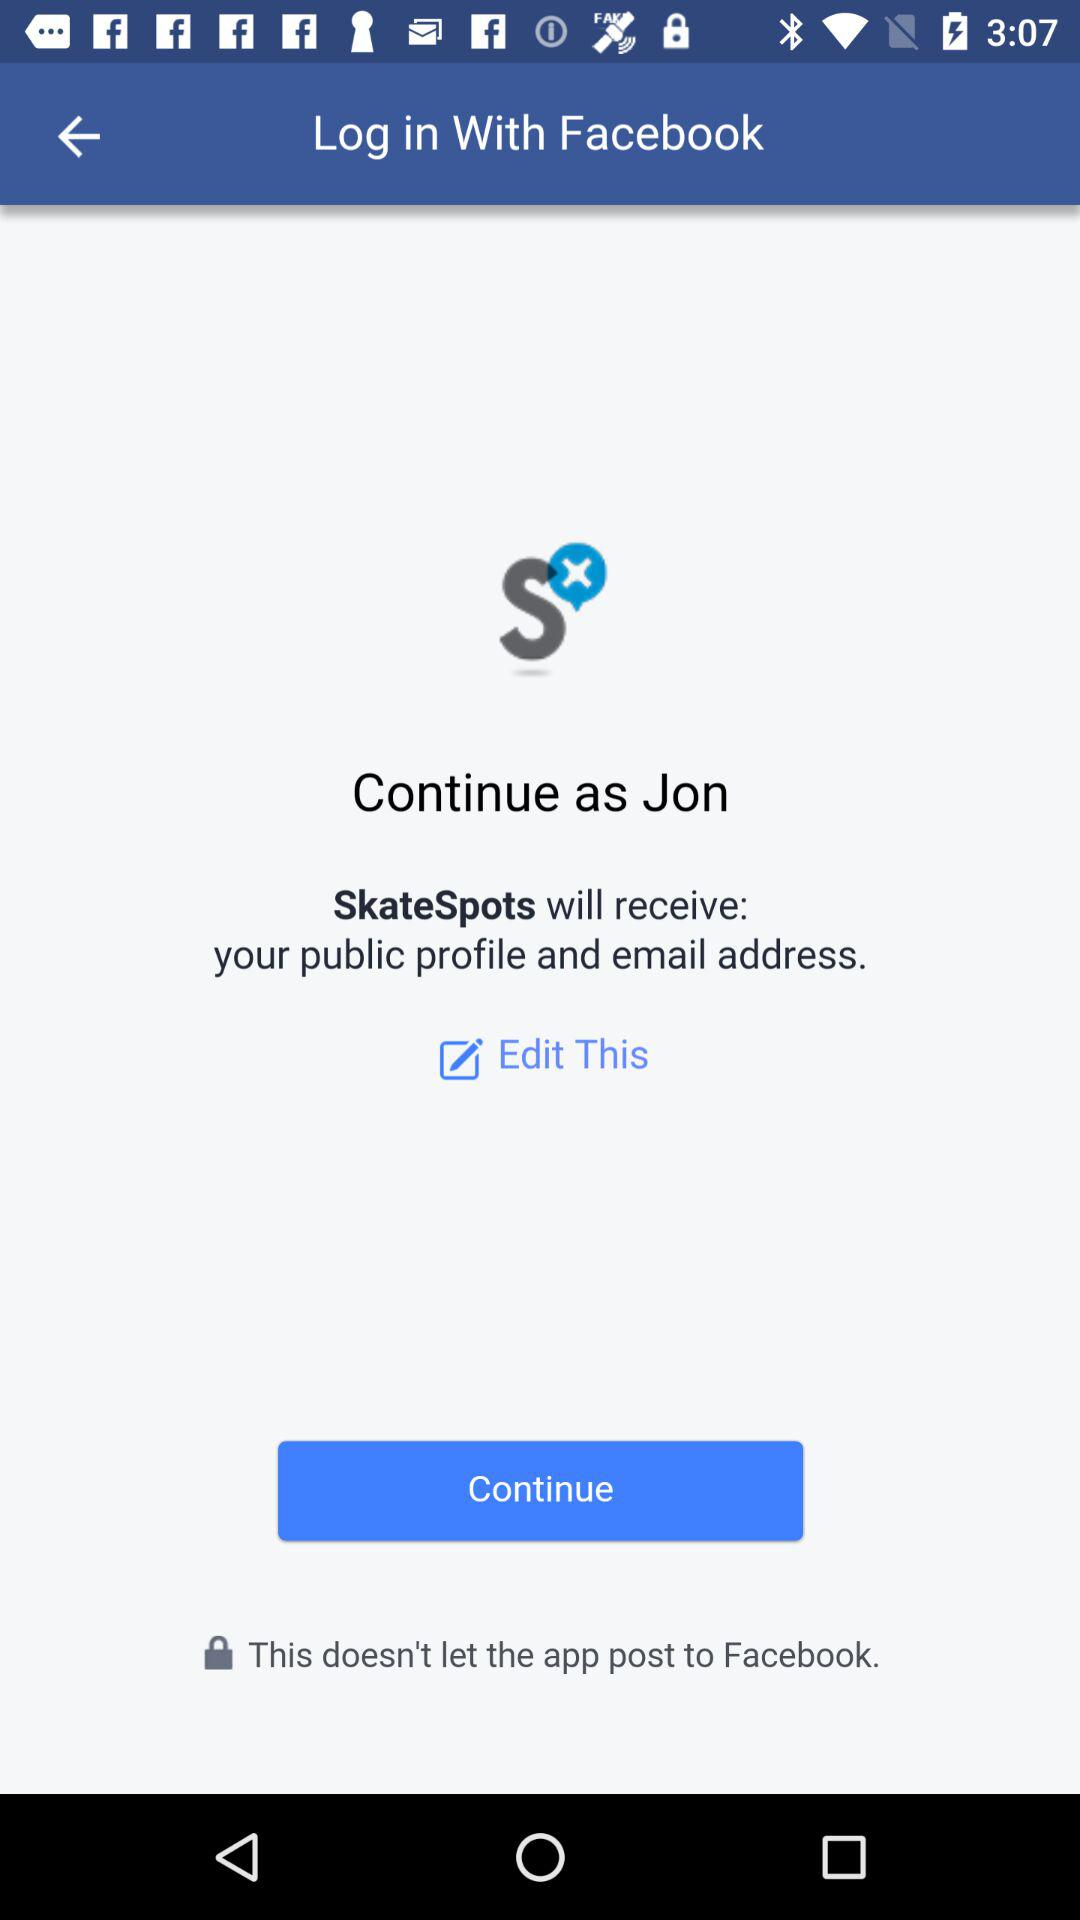What is the user name? The user name is Jon. 